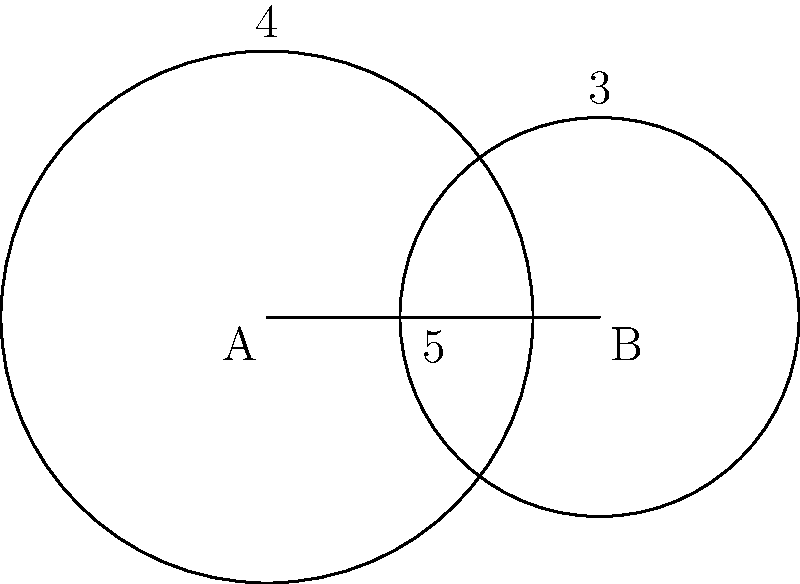In a mixed-gender sports competition, two teams are represented by overlapping circles. Circle A has a radius of 4 units, representing the male athletes, while Circle B has a radius of 3 units, representing the female athletes. The centers of the circles are 5 units apart. Calculate the area of overlap between the two circles, which represents the mixed-gender portion of the teams. To find the area of overlap between two circles, we'll use the following steps:

1) First, we need to calculate the distance from the center of each circle to the line joining the points of intersection. Let's call this distance $d$.

2) We can use the Pythagorean theorem to find $d$:

   $d^2 + (\frac{5}{2})^2 = 4^2$
   
   $d^2 = 16 - \frac{25}{4} = \frac{39}{4}$
   
   $d = \frac{\sqrt{39}}{2}$

3) Now, we can calculate the angle $\theta$ (in radians) for each circle:

   For Circle A: $\cos(\frac{\theta_A}{2}) = \frac{d}{4}$, so $\theta_A = 2\arccos(\frac{\sqrt{39}}{8})$
   
   For Circle B: $\cos(\frac{\theta_B}{2}) = \frac{d}{3}$, so $\theta_B = 2\arccos(\frac{\sqrt{39}}{6})$

4) The area of overlap is the sum of two circular segments minus the area of the rhombus formed by the radii:

   Area = $4^2 \cdot \frac{\theta_A}{2} - 4^2 \cdot \sin(\frac{\theta_A}{2}) \cdot \cos(\frac{\theta_A}{2}) + 3^2 \cdot \frac{\theta_B}{2} - 3^2 \cdot \sin(\frac{\theta_B}{2}) \cdot \cos(\frac{\theta_B}{2}) - 5d$

5) Substituting the values and calculating:

   Area ≈ 9.74 square units
Answer: 9.74 square units 